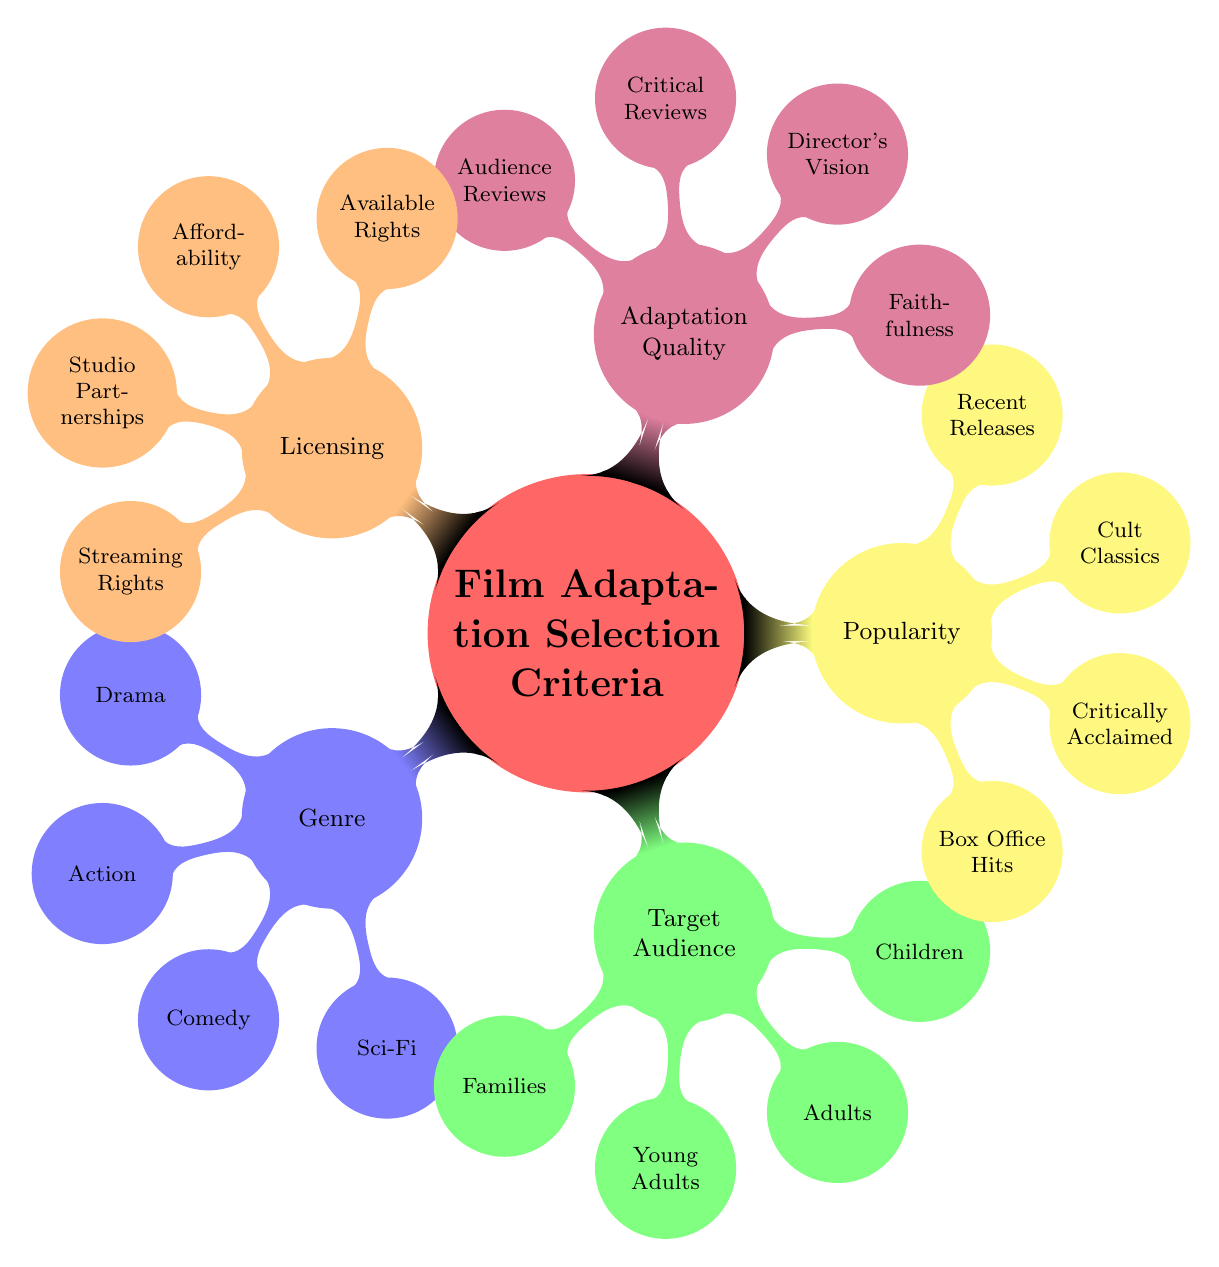What are the two main categories under the "Adaptation Quality"? The "Adaptation Quality" branch has four categories under it: "Faithfulness", "Director's Vision", "Critical Reviews", and "Audience Reviews". Thus, the two main categories are "Faithfulness" and "Director's Vision".
Answer: Faithfulness, Director's Vision Which genre includes a classic literature adaptation? Under the "Popularity" section, "Classic Literature Adaptations" is listed as a type of popular film adaptation. The specific classic mentioned is "Pride and Prejudice".
Answer: Pride and Prejudice How many target audience categories are in the mind map? The "Target Audience" section includes five categories: Families, Young Adults, Adults, Children, and Seniors. Counting these categories gives a total of five.
Answer: 5 What is one reason to incorporate studio partnerships in film adaptations? The "Licensing" category includes "Studio Partnerships" as a criterion, indicating it is a valid factor for selecting adaptations to broaden reach or obtain support from major studios.
Answer: Warner Bros Which film is associated with science fiction in the genre category? In the "Genre" section, "Science Fiction" is specifically paired with "Blade Runner". Therefore, "Blade Runner" is the associated science fiction film.
Answer: Blade Runner What allows for a variety of film options under the "Licensing" criteria? The "Licensing" section contains multiple branches including "Available Rights", "Affordability", "Studio Partnerships", "Local or Independent Films", and "Streaming Rights". Each of these options allows for a different range of films, enhancing diversity.
Answer: Various options Name a film associated with the target audience of seniors. The "Target Audience" section specifically lists "The Best Exotic Marigold Hotel" under the seniors category, highlighting its targeted appeal.
Answer: The Best Exotic Marigold Hotel Which film is regarded as a box office hit in the popularity category? In the "Popularity" section, "Box Office Hits" is associated with "Avengers: Endgame", signifying its financial success at the box office.
Answer: Avengers: Endgame What film adaptation is noted for critical reviews? The "Adaptation Quality" section lists "Parasite" under "Critical Reviews", indicating its recognition and positive reviews by critics.
Answer: Parasite 